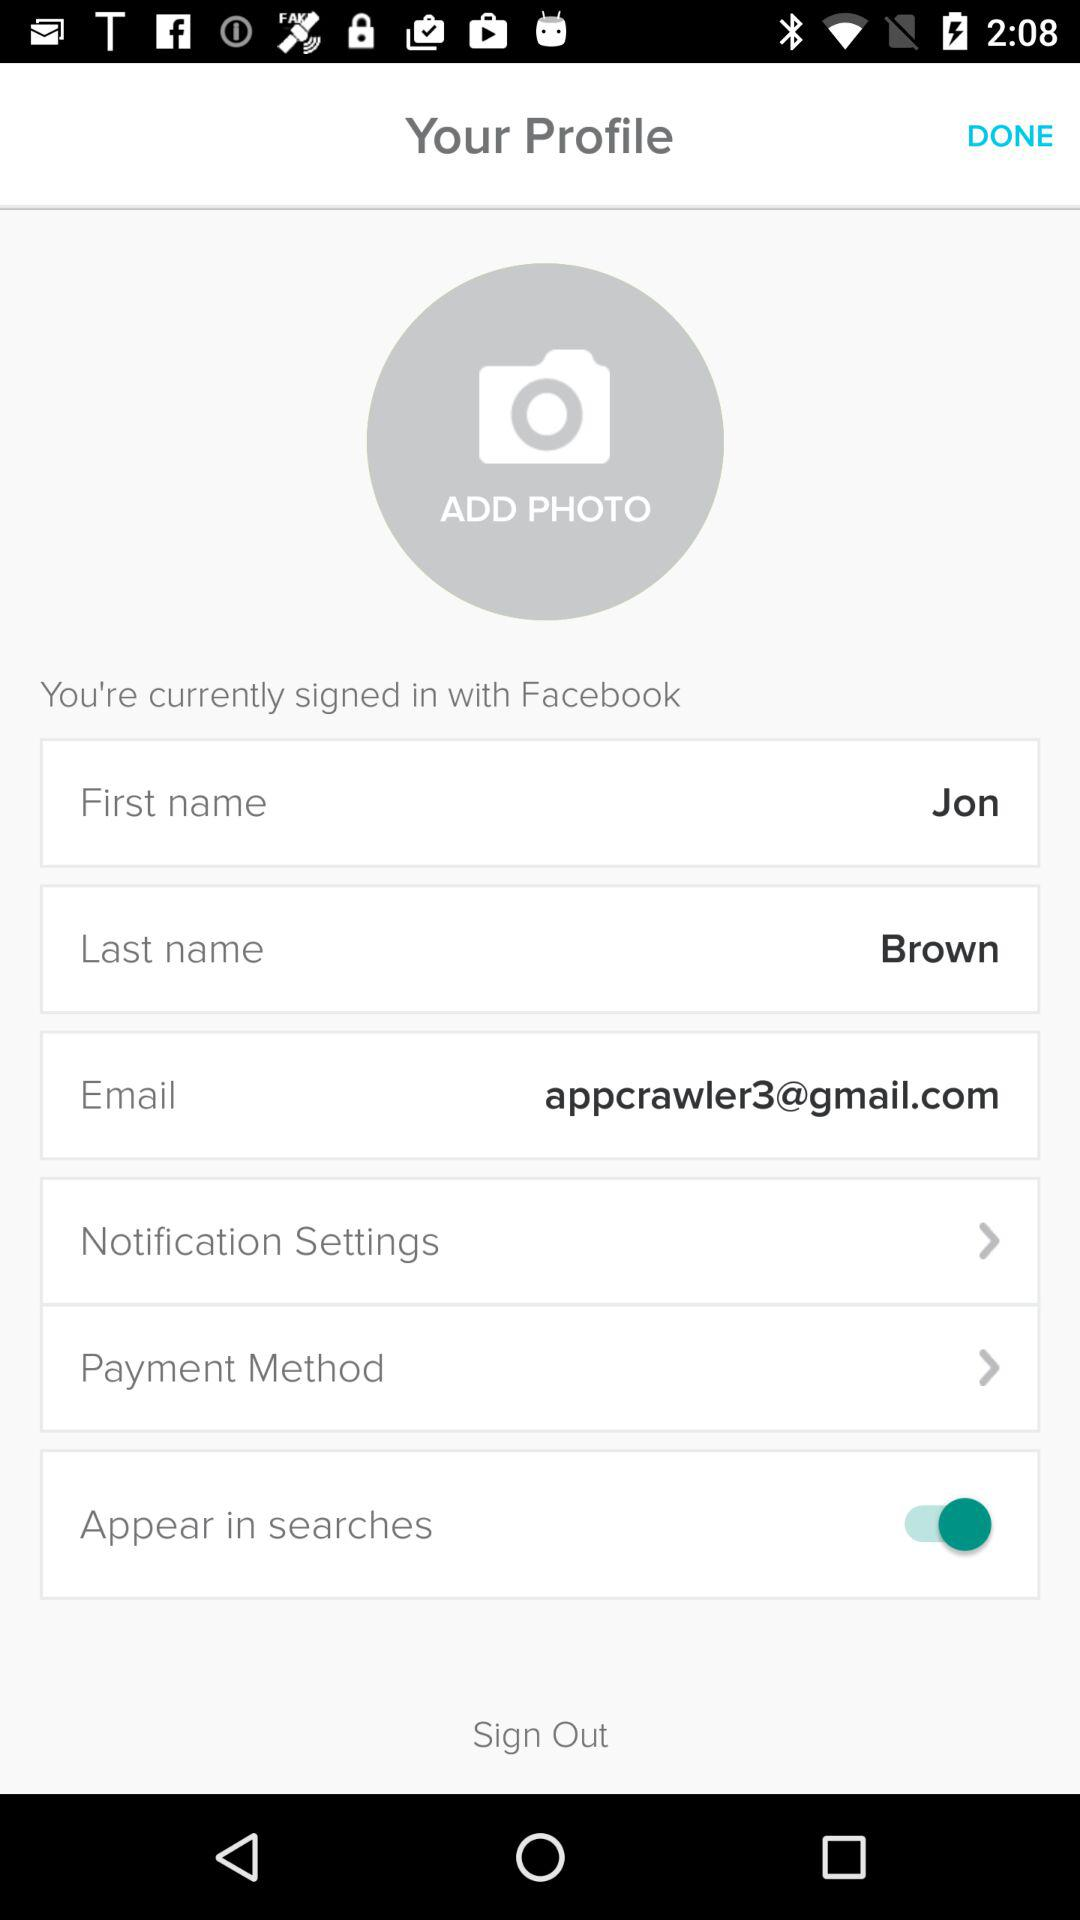Which payment methods are available to the user?
When the provided information is insufficient, respond with <no answer>. <no answer> 